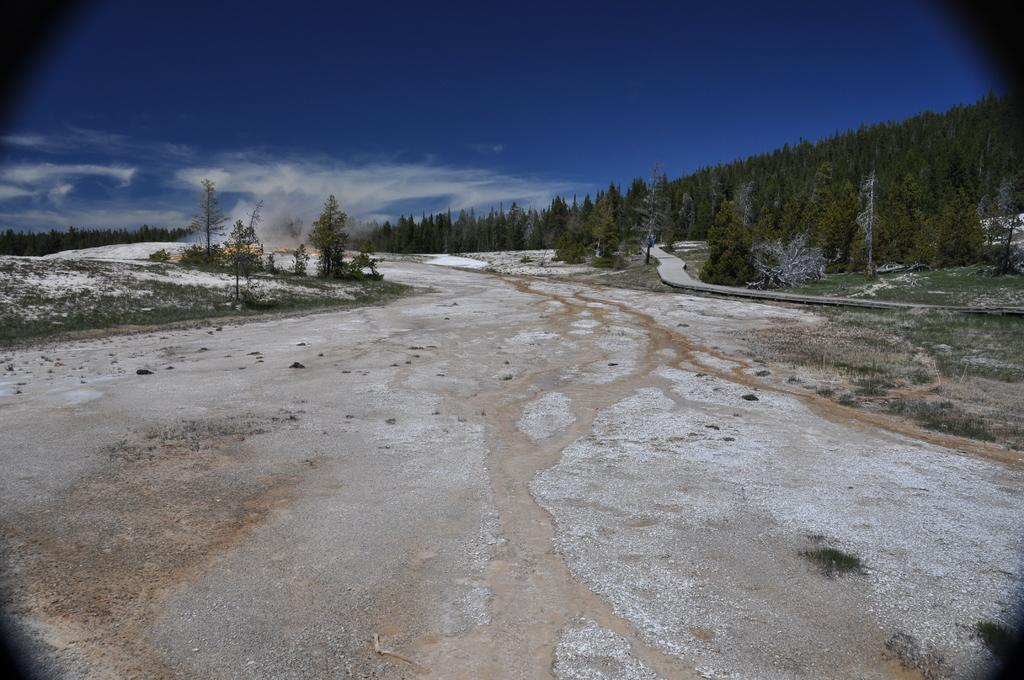What type of vegetation can be seen in the image? There are trees in the image. What is covering the ground in the image? There is grass on the ground in the image. How would you describe the sky in the image? The sky is blue and cloudy in the image. Are there any mines visible in the image? There are no mines present in the image. Can you see any cacti in the image? There are no cacti present in the image; it features trees and grass. 